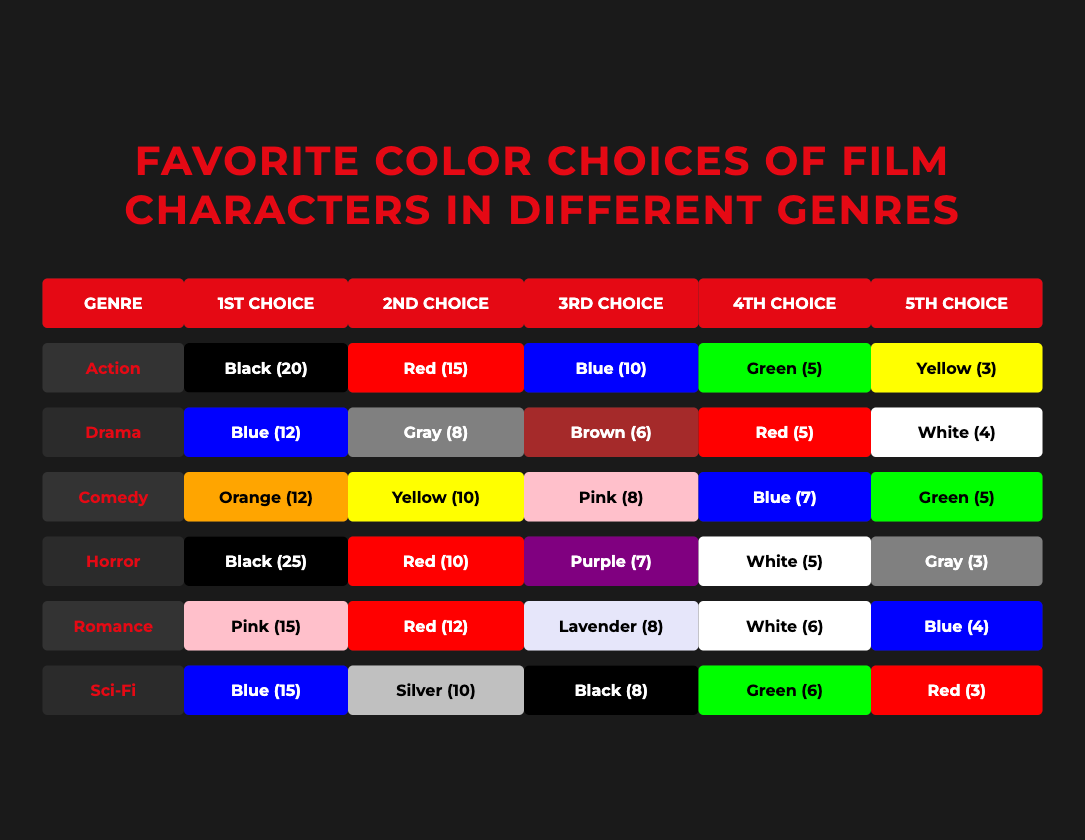What is the most popular color choice for film characters in the Horror genre? The Horror genre shows the color Black having the highest frequency with 25 choices made.
Answer: Black What color is the 3rd choice for the Romance genre? The 3rd choice listed for the Romance genre is Lavender with a frequency of 8.
Answer: Lavender Which genre has the least favorite color choice in the 5th slot? Examining the 5th choices across genres, the least is Yellow with a frequency of 3 in the Action genre.
Answer: Yellow What is the sum of the top three color choices in the Action genre? The top three color choices are Black (20), Red (15), and Blue (10). Adding these gives 20 + 15 + 10 = 45.
Answer: 45 Is Blue the most popular color choice overall across all genres? No, Black in the Horror genre has a frequency of 25, which is higher than any Blue choices.
Answer: No How many color choices are listed for the Comedy genre? The Comedy genre has a total of 5 color choices listed: Orange, Yellow, Pink, Blue, and Green.
Answer: 5 Which color is the 2nd most chosen color in the Drama genre? The second most chosen color in the Drama genre is Gray, with a frequency of 8, following Blue, which has 12.
Answer: Gray What is the average frequency of color choices for the Action genre? The frequencies for the Action genre are 20 (Black), 15 (Red), 10 (Blue), 5 (Green), and 3 (Yellow), resulting in an average of (20 + 15 + 10 + 5 + 3) / 5 = 53 / 5 = 10.6.
Answer: 10.6 In which genre do characters predominantly choose Pink? Pink is predominantly chosen in the Romance genre, where it has the frequency of 15.
Answer: Romance 